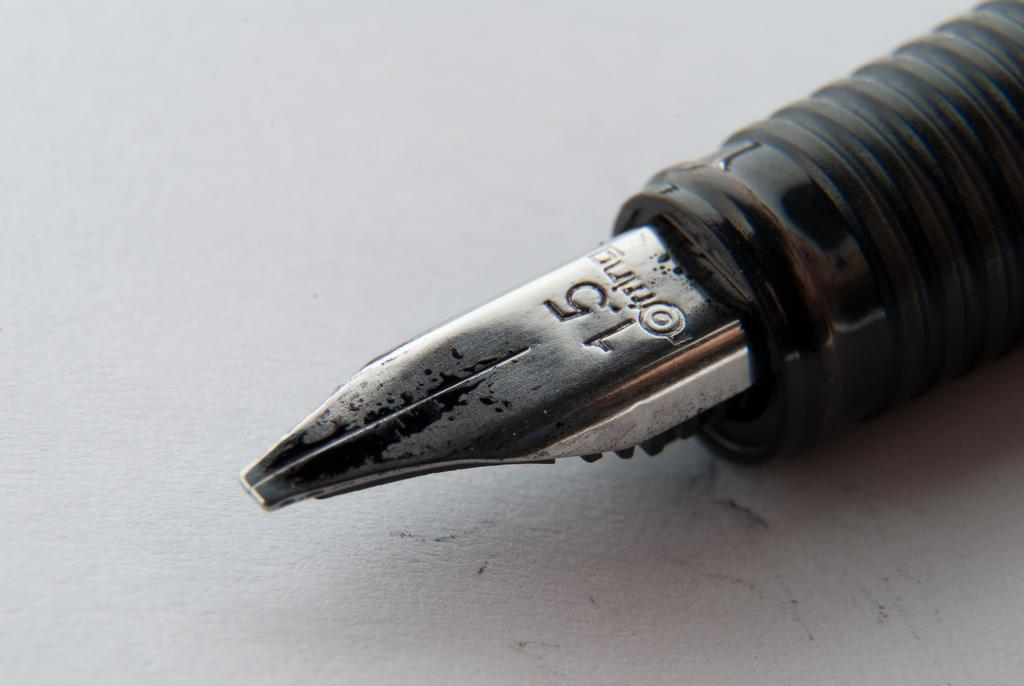What object is visible in the image? There is an ink pen in the image. What is the ink pen placed on? The ink pen is on a white surface. How many cats are sitting on the roof in the image? There are no cats or roofs present in the image; it only features an ink pen on a white surface. 